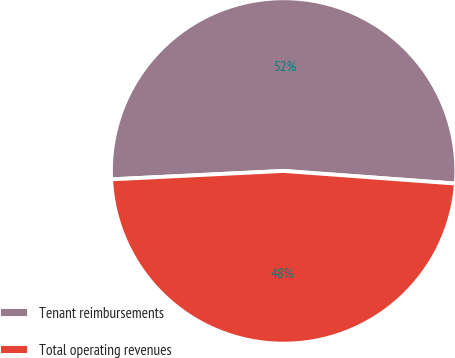<chart> <loc_0><loc_0><loc_500><loc_500><pie_chart><fcel>Tenant reimbursements<fcel>Total operating revenues<nl><fcel>51.94%<fcel>48.06%<nl></chart> 